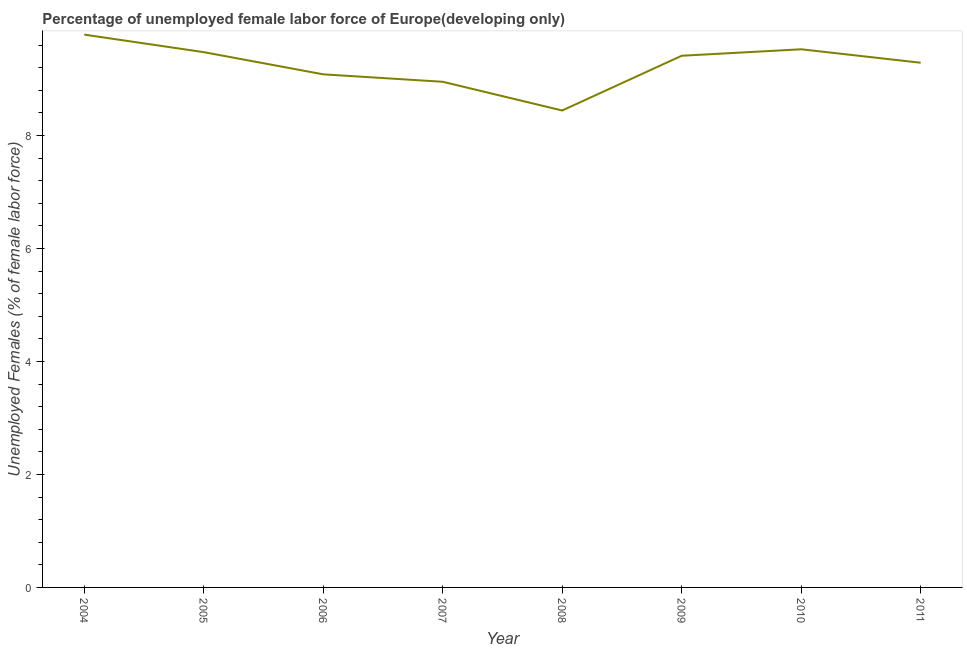What is the total unemployed female labour force in 2007?
Your answer should be very brief. 8.95. Across all years, what is the maximum total unemployed female labour force?
Your answer should be compact. 9.78. Across all years, what is the minimum total unemployed female labour force?
Offer a terse response. 8.44. What is the sum of the total unemployed female labour force?
Your response must be concise. 73.95. What is the difference between the total unemployed female labour force in 2005 and 2009?
Your response must be concise. 0.06. What is the average total unemployed female labour force per year?
Provide a succinct answer. 9.24. What is the median total unemployed female labour force?
Offer a very short reply. 9.35. In how many years, is the total unemployed female labour force greater than 7.6 %?
Your answer should be very brief. 8. What is the ratio of the total unemployed female labour force in 2005 to that in 2007?
Keep it short and to the point. 1.06. What is the difference between the highest and the second highest total unemployed female labour force?
Your answer should be compact. 0.26. What is the difference between the highest and the lowest total unemployed female labour force?
Ensure brevity in your answer.  1.34. How many lines are there?
Ensure brevity in your answer.  1. Are the values on the major ticks of Y-axis written in scientific E-notation?
Make the answer very short. No. Does the graph contain any zero values?
Ensure brevity in your answer.  No. What is the title of the graph?
Your answer should be compact. Percentage of unemployed female labor force of Europe(developing only). What is the label or title of the Y-axis?
Keep it short and to the point. Unemployed Females (% of female labor force). What is the Unemployed Females (% of female labor force) in 2004?
Offer a very short reply. 9.78. What is the Unemployed Females (% of female labor force) in 2005?
Offer a terse response. 9.47. What is the Unemployed Females (% of female labor force) in 2006?
Your answer should be compact. 9.08. What is the Unemployed Females (% of female labor force) in 2007?
Your response must be concise. 8.95. What is the Unemployed Females (% of female labor force) of 2008?
Your answer should be very brief. 8.44. What is the Unemployed Females (% of female labor force) of 2009?
Offer a very short reply. 9.41. What is the Unemployed Females (% of female labor force) in 2010?
Offer a very short reply. 9.52. What is the Unemployed Females (% of female labor force) of 2011?
Your answer should be very brief. 9.29. What is the difference between the Unemployed Females (% of female labor force) in 2004 and 2005?
Offer a very short reply. 0.31. What is the difference between the Unemployed Females (% of female labor force) in 2004 and 2006?
Make the answer very short. 0.7. What is the difference between the Unemployed Females (% of female labor force) in 2004 and 2007?
Offer a very short reply. 0.83. What is the difference between the Unemployed Females (% of female labor force) in 2004 and 2008?
Your answer should be compact. 1.34. What is the difference between the Unemployed Females (% of female labor force) in 2004 and 2009?
Ensure brevity in your answer.  0.37. What is the difference between the Unemployed Females (% of female labor force) in 2004 and 2010?
Offer a very short reply. 0.26. What is the difference between the Unemployed Females (% of female labor force) in 2004 and 2011?
Give a very brief answer. 0.5. What is the difference between the Unemployed Females (% of female labor force) in 2005 and 2006?
Your answer should be very brief. 0.39. What is the difference between the Unemployed Females (% of female labor force) in 2005 and 2007?
Your answer should be very brief. 0.52. What is the difference between the Unemployed Females (% of female labor force) in 2005 and 2008?
Provide a short and direct response. 1.03. What is the difference between the Unemployed Females (% of female labor force) in 2005 and 2009?
Provide a short and direct response. 0.06. What is the difference between the Unemployed Females (% of female labor force) in 2005 and 2010?
Provide a succinct answer. -0.05. What is the difference between the Unemployed Females (% of female labor force) in 2005 and 2011?
Offer a very short reply. 0.19. What is the difference between the Unemployed Females (% of female labor force) in 2006 and 2007?
Offer a very short reply. 0.13. What is the difference between the Unemployed Females (% of female labor force) in 2006 and 2008?
Make the answer very short. 0.64. What is the difference between the Unemployed Females (% of female labor force) in 2006 and 2009?
Make the answer very short. -0.33. What is the difference between the Unemployed Females (% of female labor force) in 2006 and 2010?
Offer a very short reply. -0.44. What is the difference between the Unemployed Females (% of female labor force) in 2006 and 2011?
Your answer should be very brief. -0.2. What is the difference between the Unemployed Females (% of female labor force) in 2007 and 2008?
Your response must be concise. 0.51. What is the difference between the Unemployed Females (% of female labor force) in 2007 and 2009?
Make the answer very short. -0.46. What is the difference between the Unemployed Females (% of female labor force) in 2007 and 2010?
Offer a very short reply. -0.58. What is the difference between the Unemployed Females (% of female labor force) in 2007 and 2011?
Your answer should be very brief. -0.34. What is the difference between the Unemployed Females (% of female labor force) in 2008 and 2009?
Offer a very short reply. -0.97. What is the difference between the Unemployed Females (% of female labor force) in 2008 and 2010?
Offer a terse response. -1.08. What is the difference between the Unemployed Females (% of female labor force) in 2008 and 2011?
Ensure brevity in your answer.  -0.85. What is the difference between the Unemployed Females (% of female labor force) in 2009 and 2010?
Offer a very short reply. -0.11. What is the difference between the Unemployed Females (% of female labor force) in 2009 and 2011?
Give a very brief answer. 0.12. What is the difference between the Unemployed Females (% of female labor force) in 2010 and 2011?
Provide a succinct answer. 0.24. What is the ratio of the Unemployed Females (% of female labor force) in 2004 to that in 2005?
Your response must be concise. 1.03. What is the ratio of the Unemployed Females (% of female labor force) in 2004 to that in 2006?
Offer a terse response. 1.08. What is the ratio of the Unemployed Females (% of female labor force) in 2004 to that in 2007?
Provide a short and direct response. 1.09. What is the ratio of the Unemployed Females (% of female labor force) in 2004 to that in 2008?
Keep it short and to the point. 1.16. What is the ratio of the Unemployed Females (% of female labor force) in 2004 to that in 2010?
Your answer should be very brief. 1.03. What is the ratio of the Unemployed Females (% of female labor force) in 2004 to that in 2011?
Provide a short and direct response. 1.05. What is the ratio of the Unemployed Females (% of female labor force) in 2005 to that in 2006?
Your response must be concise. 1.04. What is the ratio of the Unemployed Females (% of female labor force) in 2005 to that in 2007?
Keep it short and to the point. 1.06. What is the ratio of the Unemployed Females (% of female labor force) in 2005 to that in 2008?
Offer a terse response. 1.12. What is the ratio of the Unemployed Females (% of female labor force) in 2005 to that in 2011?
Ensure brevity in your answer.  1.02. What is the ratio of the Unemployed Females (% of female labor force) in 2006 to that in 2007?
Your answer should be very brief. 1.01. What is the ratio of the Unemployed Females (% of female labor force) in 2006 to that in 2008?
Your response must be concise. 1.08. What is the ratio of the Unemployed Females (% of female labor force) in 2006 to that in 2010?
Your answer should be compact. 0.95. What is the ratio of the Unemployed Females (% of female labor force) in 2006 to that in 2011?
Offer a very short reply. 0.98. What is the ratio of the Unemployed Females (% of female labor force) in 2007 to that in 2008?
Provide a succinct answer. 1.06. What is the ratio of the Unemployed Females (% of female labor force) in 2007 to that in 2009?
Offer a terse response. 0.95. What is the ratio of the Unemployed Females (% of female labor force) in 2008 to that in 2009?
Your response must be concise. 0.9. What is the ratio of the Unemployed Females (% of female labor force) in 2008 to that in 2010?
Offer a terse response. 0.89. What is the ratio of the Unemployed Females (% of female labor force) in 2008 to that in 2011?
Provide a short and direct response. 0.91. What is the ratio of the Unemployed Females (% of female labor force) in 2010 to that in 2011?
Offer a very short reply. 1.03. 